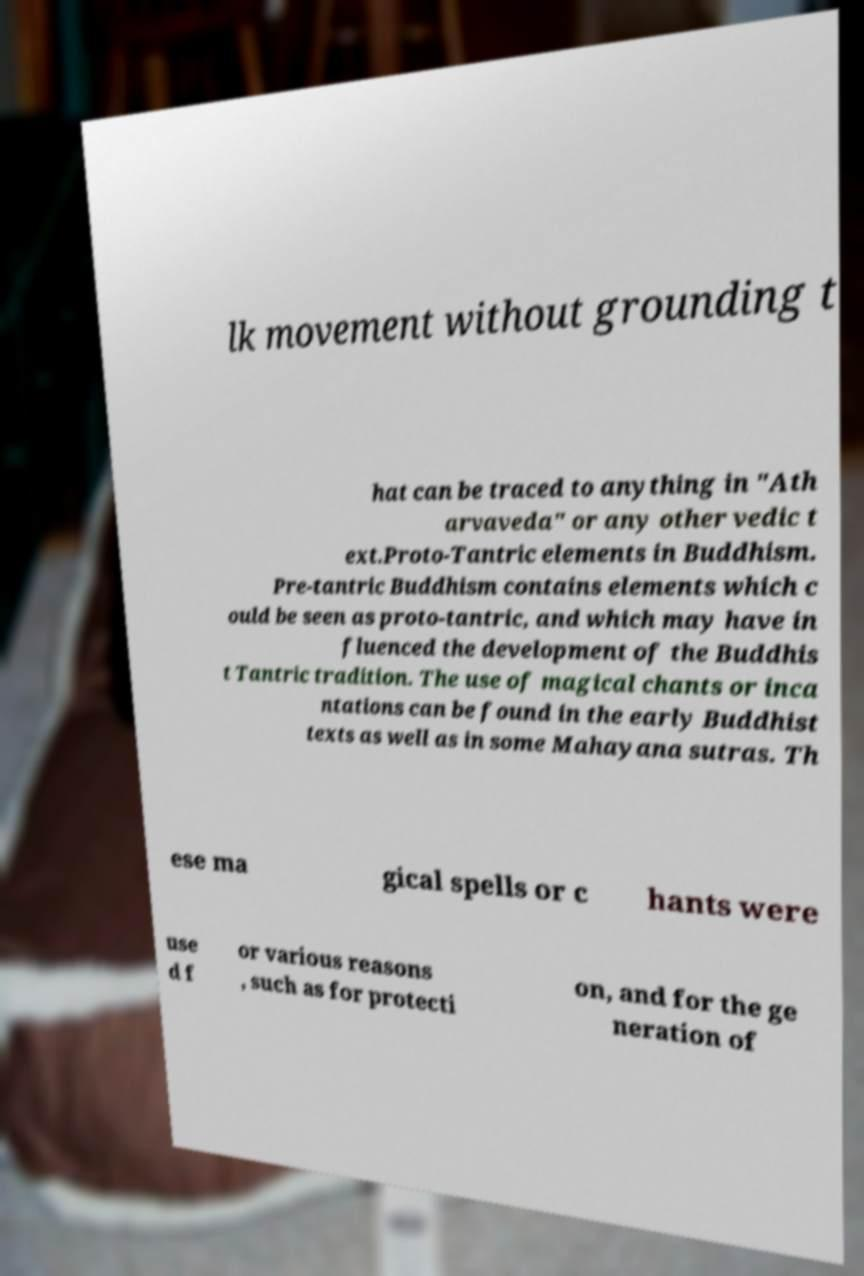For documentation purposes, I need the text within this image transcribed. Could you provide that? lk movement without grounding t hat can be traced to anything in "Ath arvaveda" or any other vedic t ext.Proto-Tantric elements in Buddhism. Pre-tantric Buddhism contains elements which c ould be seen as proto-tantric, and which may have in fluenced the development of the Buddhis t Tantric tradition. The use of magical chants or inca ntations can be found in the early Buddhist texts as well as in some Mahayana sutras. Th ese ma gical spells or c hants were use d f or various reasons , such as for protecti on, and for the ge neration of 